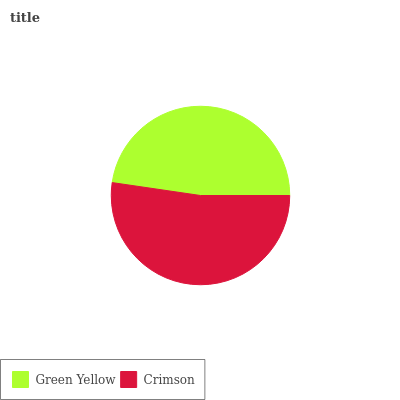Is Green Yellow the minimum?
Answer yes or no. Yes. Is Crimson the maximum?
Answer yes or no. Yes. Is Crimson the minimum?
Answer yes or no. No. Is Crimson greater than Green Yellow?
Answer yes or no. Yes. Is Green Yellow less than Crimson?
Answer yes or no. Yes. Is Green Yellow greater than Crimson?
Answer yes or no. No. Is Crimson less than Green Yellow?
Answer yes or no. No. Is Crimson the high median?
Answer yes or no. Yes. Is Green Yellow the low median?
Answer yes or no. Yes. Is Green Yellow the high median?
Answer yes or no. No. Is Crimson the low median?
Answer yes or no. No. 